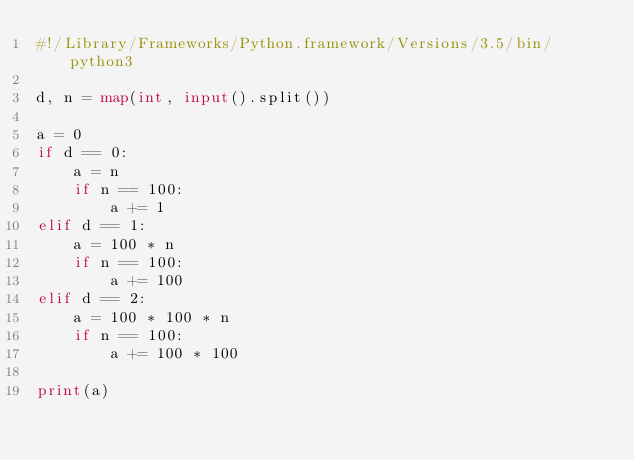Convert code to text. <code><loc_0><loc_0><loc_500><loc_500><_Python_>#!/Library/Frameworks/Python.framework/Versions/3.5/bin/python3

d, n = map(int, input().split())

a = 0
if d == 0:
    a = n
    if n == 100:
        a += 1
elif d == 1:
    a = 100 * n
    if n == 100:
        a += 100
elif d == 2:
    a = 100 * 100 * n
    if n == 100:
        a += 100 * 100

print(a)
</code> 